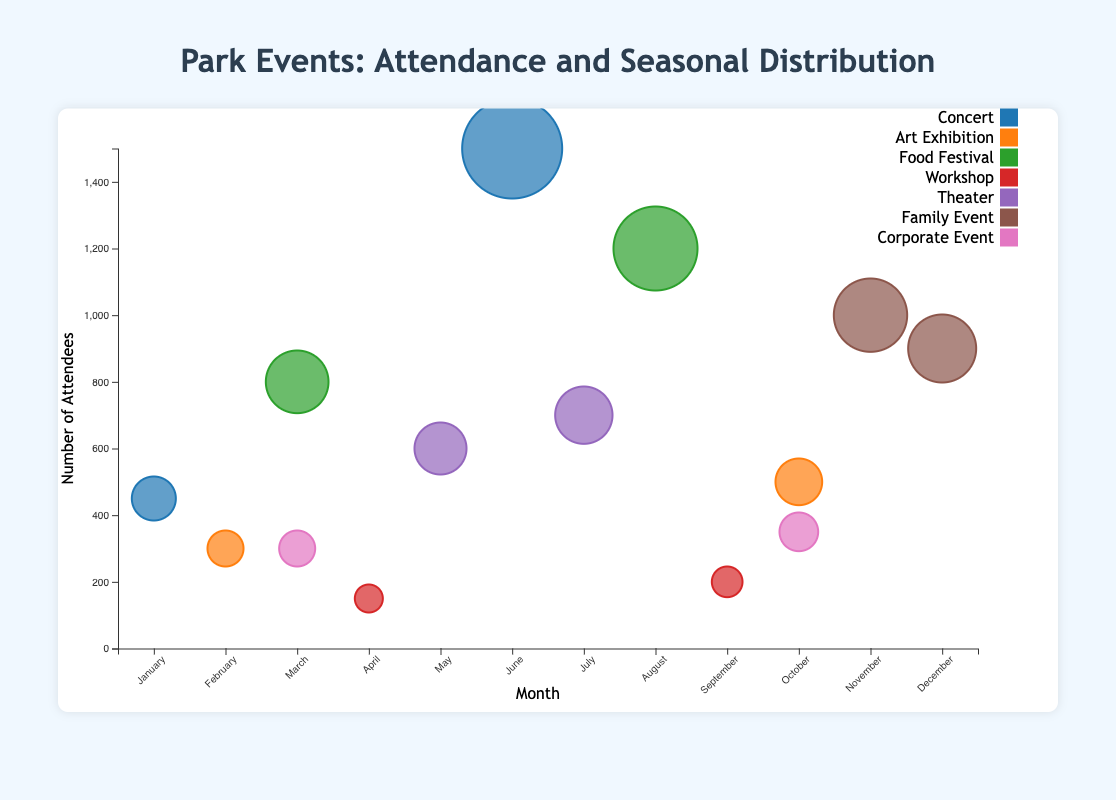Which event had the highest number of attendees? To find the event with the highest number of attendees, look for the largest bubble in the chart. The largest bubble represents the "Summer Symphony" concert in June with 1500 attendees.
Answer: Summer Symphony How many different types of events are represented in the chart? Count the unique types listed in the legend. The events are: Concert, Art Exhibition, Food Festival, Workshop, Theater, Family Event, and Corporate Event, making a total of 7 types.
Answer: 7 Which month had the most family events? Examine the bubbles labeled as "Family Event". There are Family Events in November and December. Each month has one family event. Therefore, both months had equal family events.
Answer: November and December What is the total number of attendees for all Concerts combined? Locate the bubbles representing Concerts: "Winter Music Fest" in January with 450 and "Summer Symphony" in June with 1500 attendees. Summing these gives 450 + 1500 = 1950 attendees.
Answer: 1950 Which month saw the highest number of attendees across all events? Compare the total attendees for each month by summing the attendees of all events held in that month. June had the highest attendees with 1500 from "Summer Symphony" alone. Other months do not surpass this total.
Answer: June Which event type had the least average number of attendees? Calculate the average attendees for each event type. Workshops have "Gardening 101" in April with 150 and "Outdoor Photography" in September with 200. Average is (150 + 200) / 2 = 175. This is lower than the average for other event types.
Answer: Workshop Which months had events with attendees between 800 and 1000? Identify bubbles where the y-values (number of attendees) fall between 800 and 1000. The months are March ("Spring Food Fest" with 800) and November ("Thanksgiving Picnic" with 1000).
Answer: March and November How does the number of attendees compare between Art Exhibitions and Theaters? Compare the sum of attendees. Art Exhibitions: "Winter Art Show" (300) + "Autumn Art Fair" (500) = 800. Theaters: "Shakespeare in the Park" (600) + "Summer Drama Series" (700) = 1300. Theaters have more attendees.
Answer: Theaters have more What is the difference in attendee numbers between the largest and smallest event bubbles? Find the largest bubble (Summer Symphony, June, 1500 attendees) and the smallest bubble (Gardening 101, April, 150 attendees). The difference is 1500 - 150 = 1350 attendees.
Answer: 1350 Which event type is most frequent throughout the year? Count occurrences of each event type in the chart. Concerts: 2, Art Exhibitions: 2, Food Festivals: 2, Workshops: 2, Theaters: 2, Family Events: 2, Corporate Events: 2. All types occurred equally, each with 2 events throughout the year.
Answer: All types are equal 